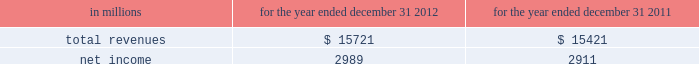See note 10 goodwill and other intangible assets for further discussion of the accounting for goodwill and other intangible assets .
The estimated amount of rbc bank ( usa ) revenue and net income ( excluding integration costs ) included in pnc 2019s consolidated income statement for 2012 was $ 1.0 billion and $ 273 million , respectively .
Upon closing and conversion of the rbc bank ( usa ) transaction , subsequent to march 2 , 2012 , separate records for rbc bank ( usa ) as a stand-alone business have not been maintained as the operations of rbc bank ( usa ) have been fully integrated into pnc .
Rbc bank ( usa ) revenue and earnings disclosed above reflect management 2019s best estimate , based on information available at the reporting date .
The table presents certain unaudited pro forma information for illustrative purposes only , for 2012 and 2011 as if rbc bank ( usa ) had been acquired on january 1 , 2011 .
The unaudited estimated pro forma information combines the historical results of rbc bank ( usa ) with the company 2019s consolidated historical results and includes certain adjustments reflecting the estimated impact of certain fair value adjustments for the respective periods .
The pro forma information is not indicative of what would have occurred had the acquisition taken place on january 1 , 2011 .
In particular , no adjustments have been made to eliminate the impact of other-than-temporary impairment losses and losses recognized on the sale of securities that may not have been necessary had the investment securities been recorded at fair value as of january 1 , 2011 .
The unaudited pro forma information does not consider any changes to the provision for credit losses resulting from recording loan assets at fair value .
Additionally , the pro forma financial information does not include the impact of possible business model changes and does not reflect pro forma adjustments to conform accounting policies between rbc bank ( usa ) and pnc .
Additionally , pnc expects to achieve further operating cost savings and other business synergies , including revenue growth , as a result of the acquisition that are not reflected in the pro forma amounts that follow .
As a result , actual results will differ from the unaudited pro forma information presented .
Table 57 : rbc bank ( usa ) and pnc unaudited pro forma results .
In connection with the rbc bank ( usa ) acquisition and other prior acquisitions , pnc recognized $ 267 million of integration charges in 2012 .
Pnc recognized $ 42 million of integration charges in 2011 in connection with prior acquisitions .
The integration charges are included in the table above .
Sale of smartstreet effective october 26 , 2012 , pnc divested certain deposits and assets of the smartstreet business unit , which was acquired by pnc as part of the rbc bank ( usa ) acquisition , to union bank , n.a .
Smartstreet is a nationwide business focused on homeowner or community association managers and had approximately $ 1 billion of assets and deposits as of september 30 , 2012 .
The gain on sale was immaterial and resulted in a reduction of goodwill and core deposit intangibles of $ 46 million and $ 13 million , respectively .
Results from operations of smartstreet from march 2 , 2012 through october 26 , 2012 are included in our consolidated income statement .
Flagstar branch acquisition effective december 9 , 2011 , pnc acquired 27 branches in the northern metropolitan atlanta , georgia area from flagstar bank , fsb , a subsidiary of flagstar bancorp , inc .
The fair value of the assets acquired totaled approximately $ 211.8 million , including $ 169.3 million in cash , $ 24.3 million in fixed assets and $ 18.2 million of goodwill and intangible assets .
We also assumed approximately $ 210.5 million of deposits associated with these branches .
No deposit premium was paid and no loans were acquired in the transaction .
Our consolidated income statement includes the impact of the branch activity subsequent to our december 9 , 2011 acquisition .
Bankatlantic branch acquisition effective june 6 , 2011 , we acquired 19 branches in the greater tampa , florida area from bankatlantic , a subsidiary of bankatlantic bancorp , inc .
The fair value of the assets acquired totaled $ 324.9 million , including $ 256.9 million in cash , $ 26.0 million in fixed assets and $ 42.0 million of goodwill and intangible assets .
We also assumed approximately $ 324.5 million of deposits associated with these branches .
A $ 39.0 million deposit premium was paid and no loans were acquired in the transaction .
Our consolidated income statement includes the impact of the branch activity subsequent to our june 6 , 2011 acquisition .
Sale of pnc global investment servicing on july 1 , 2010 , we sold pnc global investment servicing inc .
( gis ) , a leading provider of processing , technology and business intelligence services to asset managers , broker- dealers and financial advisors worldwide , for $ 2.3 billion in cash pursuant to a definitive agreement entered into on february 2 , 2010 .
This transaction resulted in a pretax gain of $ 639 million , net of transaction costs , in the third quarter of 2010 .
This gain and results of operations of gis through june 30 , 2010 are presented as income from discontinued operations , net of income taxes , on our consolidated income statement .
As part of the sale agreement , pnc has agreed to provide certain transitional services on behalf of gis until completion of related systems conversion activities .
138 the pnc financial services group , inc .
2013 form 10-k .
What was the profit margin in 2012? 
Computations: (2989 / 15721)
Answer: 0.19013. 